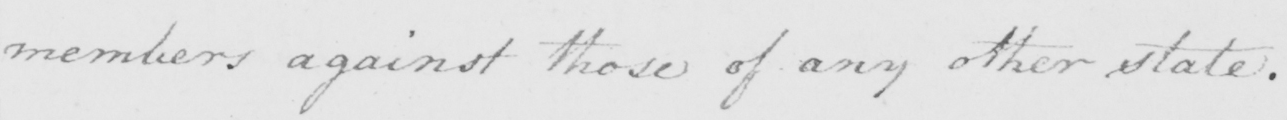Transcribe the text shown in this historical manuscript line. members against those of any other state . 